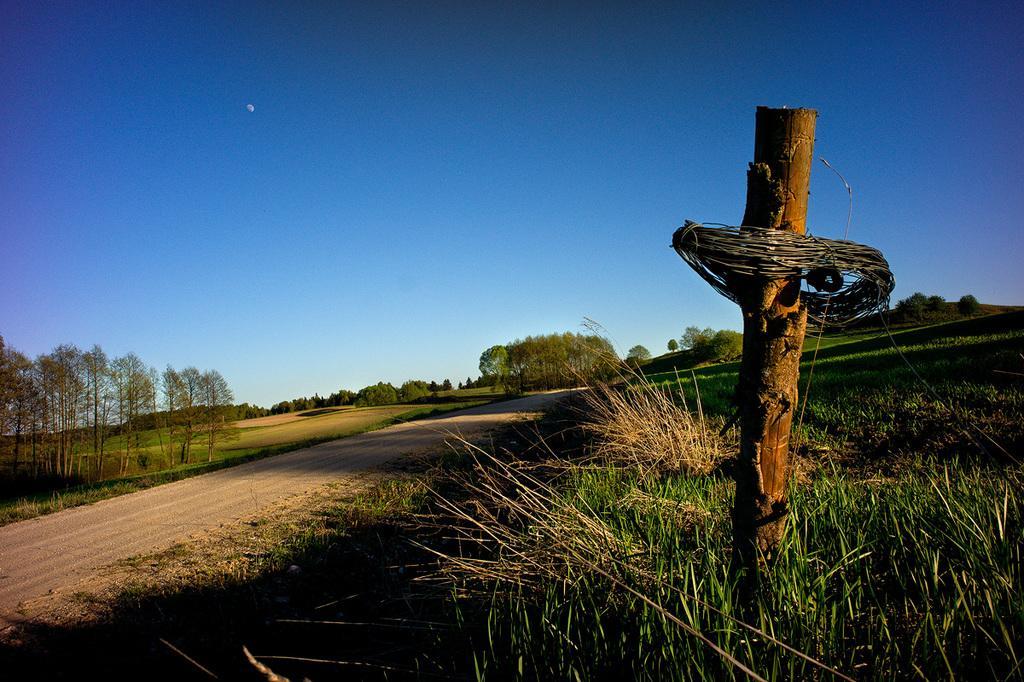Describe this image in one or two sentences. In this image I can see a wooden stick, background I can see plants and trees in green color and the sky is in blue color. 